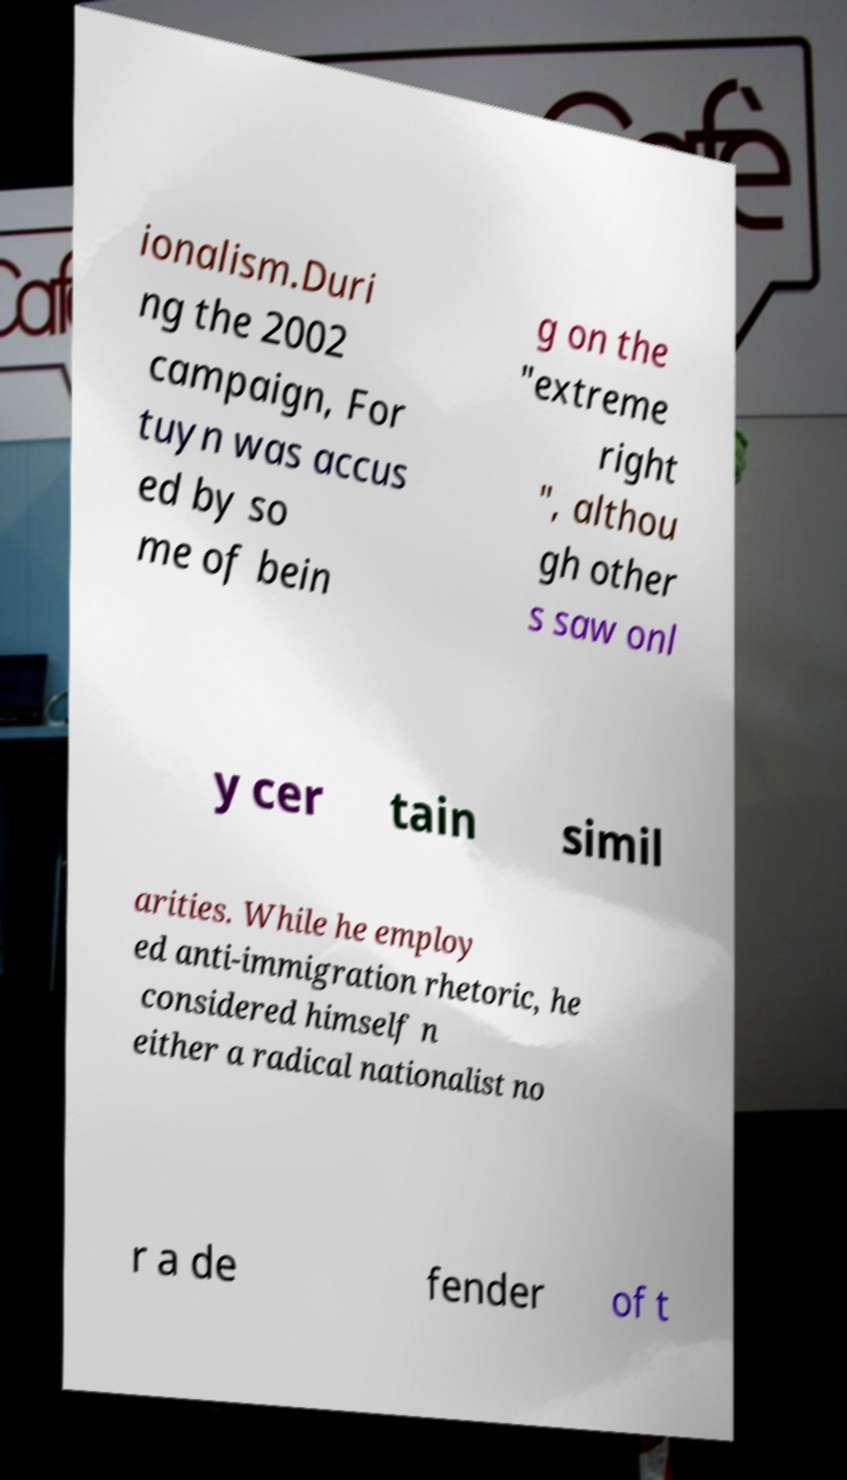Can you read and provide the text displayed in the image?This photo seems to have some interesting text. Can you extract and type it out for me? ionalism.Duri ng the 2002 campaign, For tuyn was accus ed by so me of bein g on the "extreme right ", althou gh other s saw onl y cer tain simil arities. While he employ ed anti-immigration rhetoric, he considered himself n either a radical nationalist no r a de fender of t 